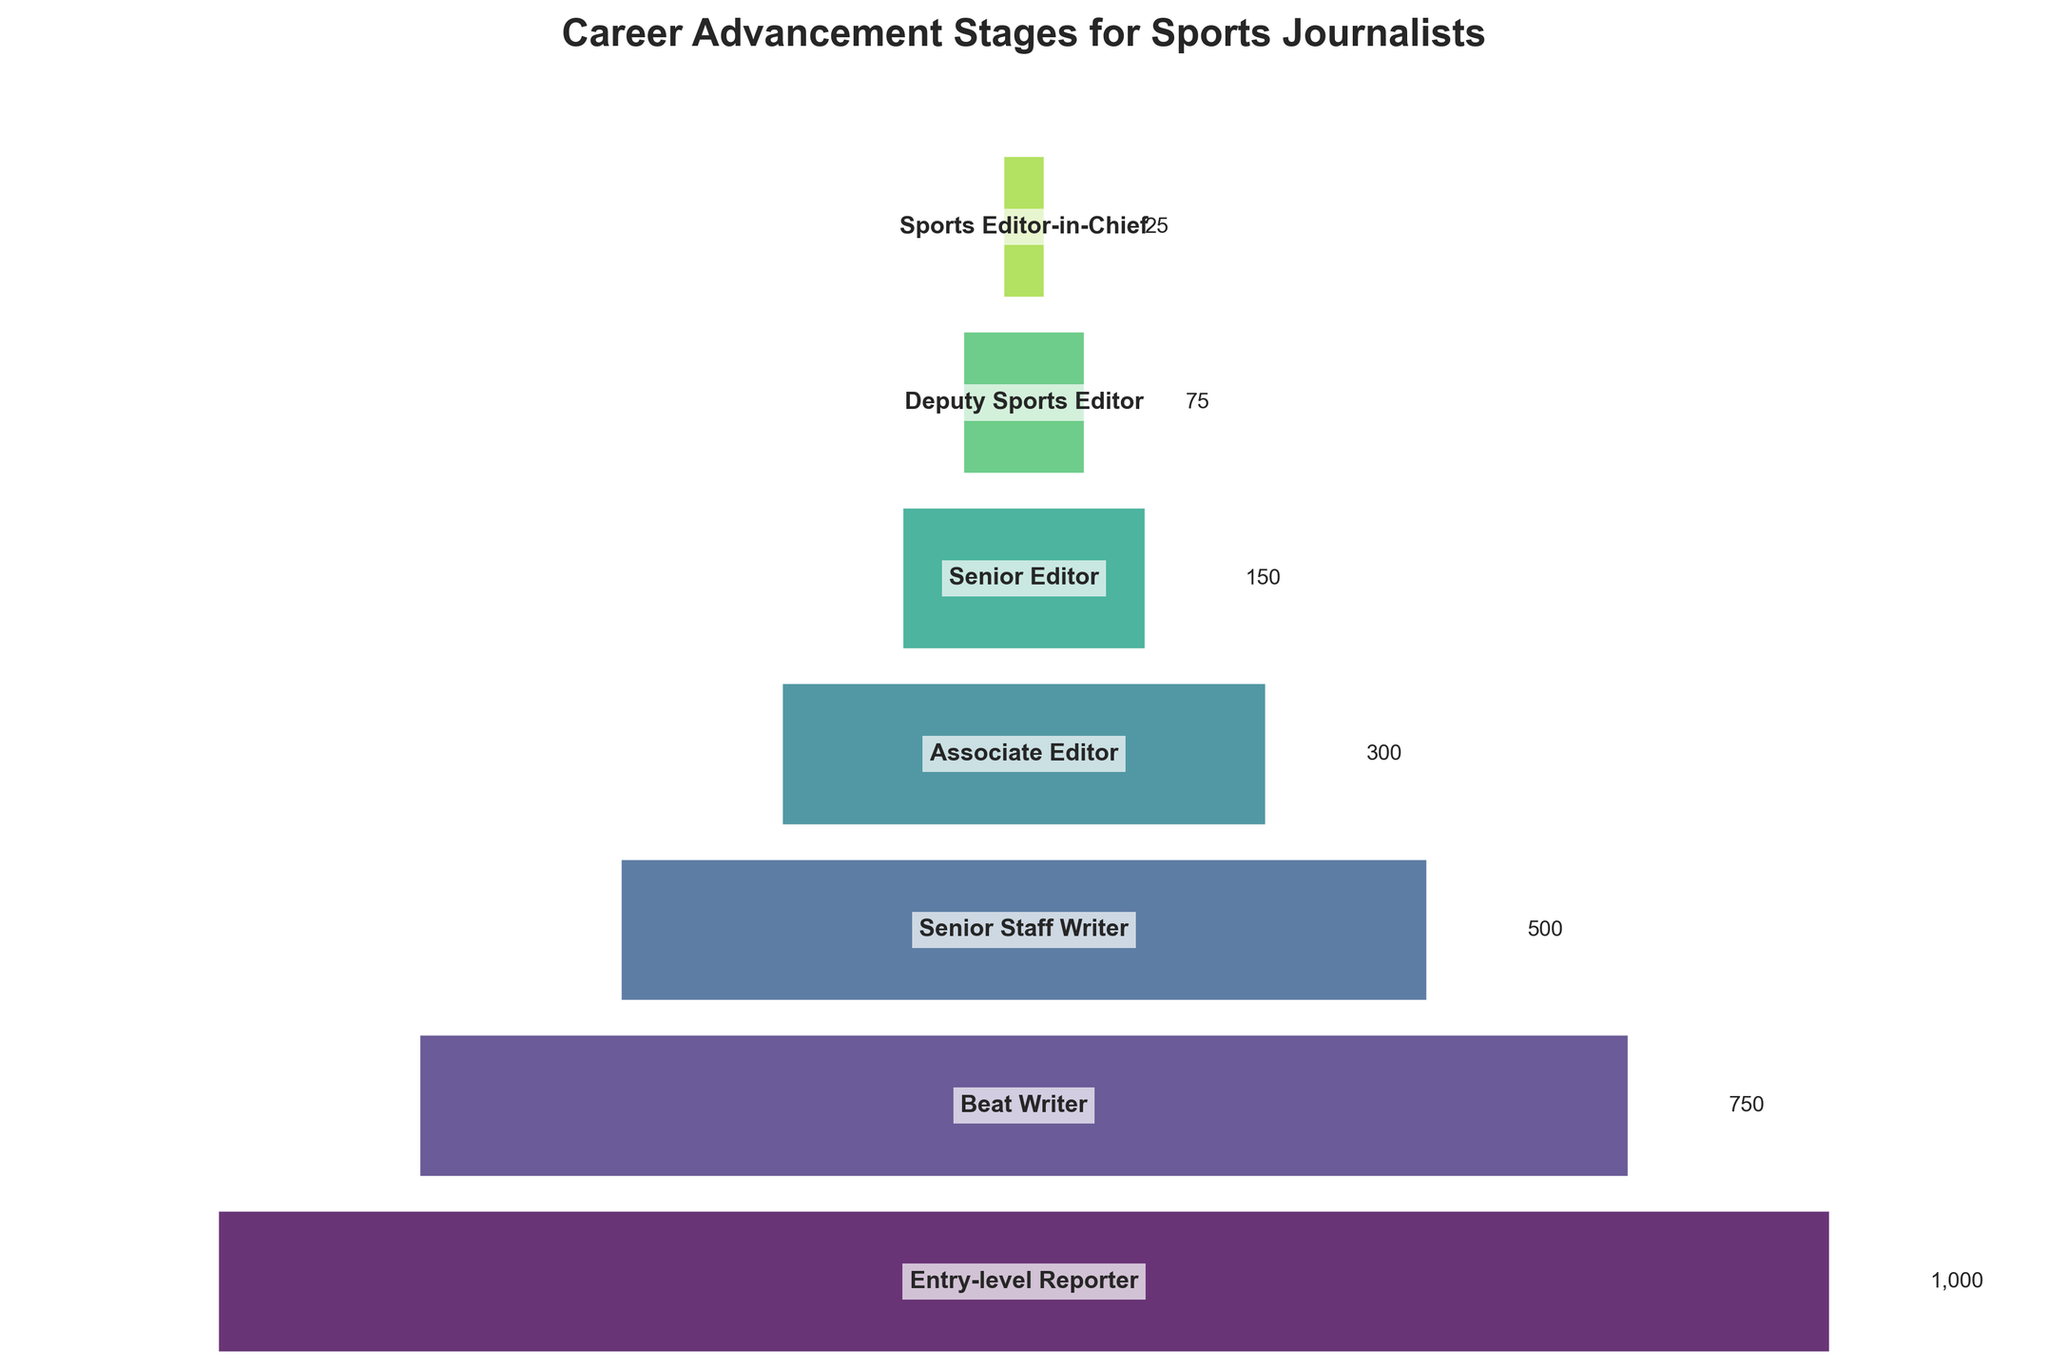What is the title of the funnel chart? The title is located at the top of the chart. It reads "Career Advancement Stages for Sports Journalists".
Answer: Career Advancement Stages for Sports Journalists How many career stages are depicted in the funnel chart? The y-axis of the funnel chart lists the career stages from Entry-level Reporter to Sports Editor-in-Chief. Counting these stages gives the total number.
Answer: 7 Which career stage has the fewest number of journalists? The chart shows the number values next to each stage. The smallest number is next to Sports Editor-in-Chief.
Answer: Sports Editor-in-Chief How many more Entry-level Reporters are there compared to Senior Editors? Find the number of journalists in each career stage (1000 for Entry-level Reporter and 150 for Senior Editor) and calculate the difference (1000 - 150).
Answer: 850 Which two career stages have a combined total of 450 journalists? Check the values and identify which two stages add up to 450 (Senior Staff Writer with 500 and Associate Editor with 300 do not work, but Deputy Sports Editor with 75 and Sports Editor-in-Chief with 25 do not work either. Verify Beat Writer with 750 and Senior Staff Writer, nope. So finally, Associate Editor with 300 and Senior Editor with 150 work).
Answer: Associate Editor and Senior Editor What is the average number of journalists across all career stages depicted in the funnel chart? Add the total number of journalists across all stages (1000 + 750 + 500 + 300 + 150 + 75 + 25 = 2800), then divide by the number of stages (2800 / 7).
Answer: 400 Which career stage represents roughly half the number of Senior Staff Writers? The number of Senior Staff Writers is 500, and half of this number is 250. The closest career stage is Associate Editor with 300 journalists.
Answer: Associate Editor Are there more Beat Writers or the combined total of Deputy Sports Editors and Sports Editors-in-Chief? The number of Beat Writers is 750. The combined number of Deputy Sports Editors (75) and Sports Editors-in-Chief (25) is 100. Compare these two figures (750 vs 100).
Answer: Beat Writers Which stage shows a significant drop in numbers immediately after it? Look for a large gap between consecutive stages. The drop from Associate Editor (300) to Senior Editor (150) is the largest significant drop.
Answer: Associate Editor to Senior Editor Which career stage has 1.5 times the number of journalists as the Deputy Sports Editors? The number of Deputy Sports Editors is 75. Calculate 1.5 times this number (75 * 1.5 = 112.5). Since the data must be a whole number, approximate to the closest stage, which is Senior Editor with 150.
Answer: Senior Editor 